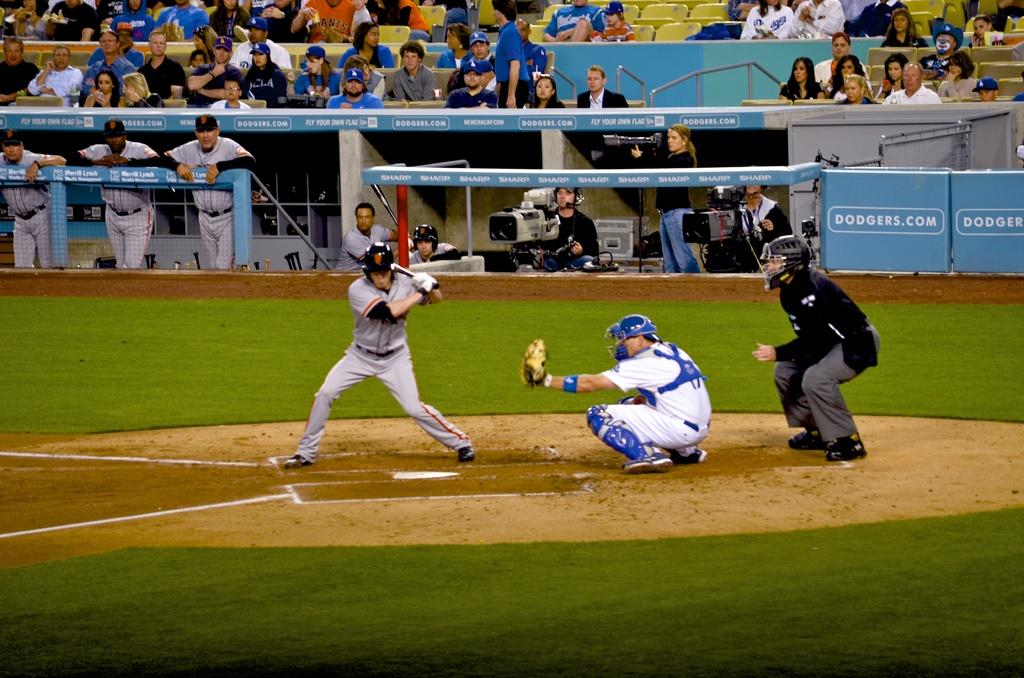<image>
Relay a brief, clear account of the picture shown. a player waiting for a pitch that has SF on his helmet 